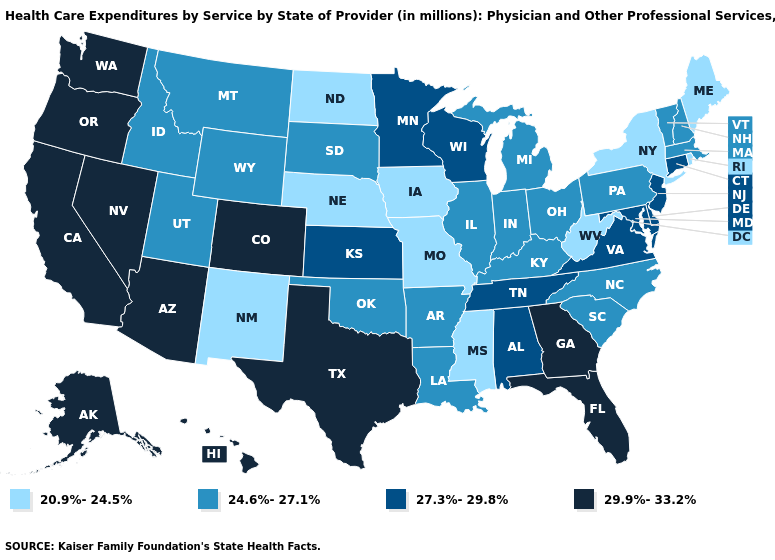Name the states that have a value in the range 27.3%-29.8%?
Write a very short answer. Alabama, Connecticut, Delaware, Kansas, Maryland, Minnesota, New Jersey, Tennessee, Virginia, Wisconsin. Among the states that border Texas , which have the highest value?
Be succinct. Arkansas, Louisiana, Oklahoma. What is the value of Illinois?
Write a very short answer. 24.6%-27.1%. Name the states that have a value in the range 24.6%-27.1%?
Quick response, please. Arkansas, Idaho, Illinois, Indiana, Kentucky, Louisiana, Massachusetts, Michigan, Montana, New Hampshire, North Carolina, Ohio, Oklahoma, Pennsylvania, South Carolina, South Dakota, Utah, Vermont, Wyoming. Among the states that border Wyoming , which have the highest value?
Answer briefly. Colorado. What is the highest value in the USA?
Be succinct. 29.9%-33.2%. Among the states that border Virginia , does Tennessee have the lowest value?
Answer briefly. No. What is the highest value in states that border Alabama?
Write a very short answer. 29.9%-33.2%. Name the states that have a value in the range 27.3%-29.8%?
Give a very brief answer. Alabama, Connecticut, Delaware, Kansas, Maryland, Minnesota, New Jersey, Tennessee, Virginia, Wisconsin. What is the highest value in the USA?
Quick response, please. 29.9%-33.2%. What is the highest value in the USA?
Concise answer only. 29.9%-33.2%. Among the states that border South Carolina , does North Carolina have the highest value?
Be succinct. No. Which states hav the highest value in the MidWest?
Quick response, please. Kansas, Minnesota, Wisconsin. What is the value of Illinois?
Keep it brief. 24.6%-27.1%. Does West Virginia have the lowest value in the USA?
Answer briefly. Yes. 